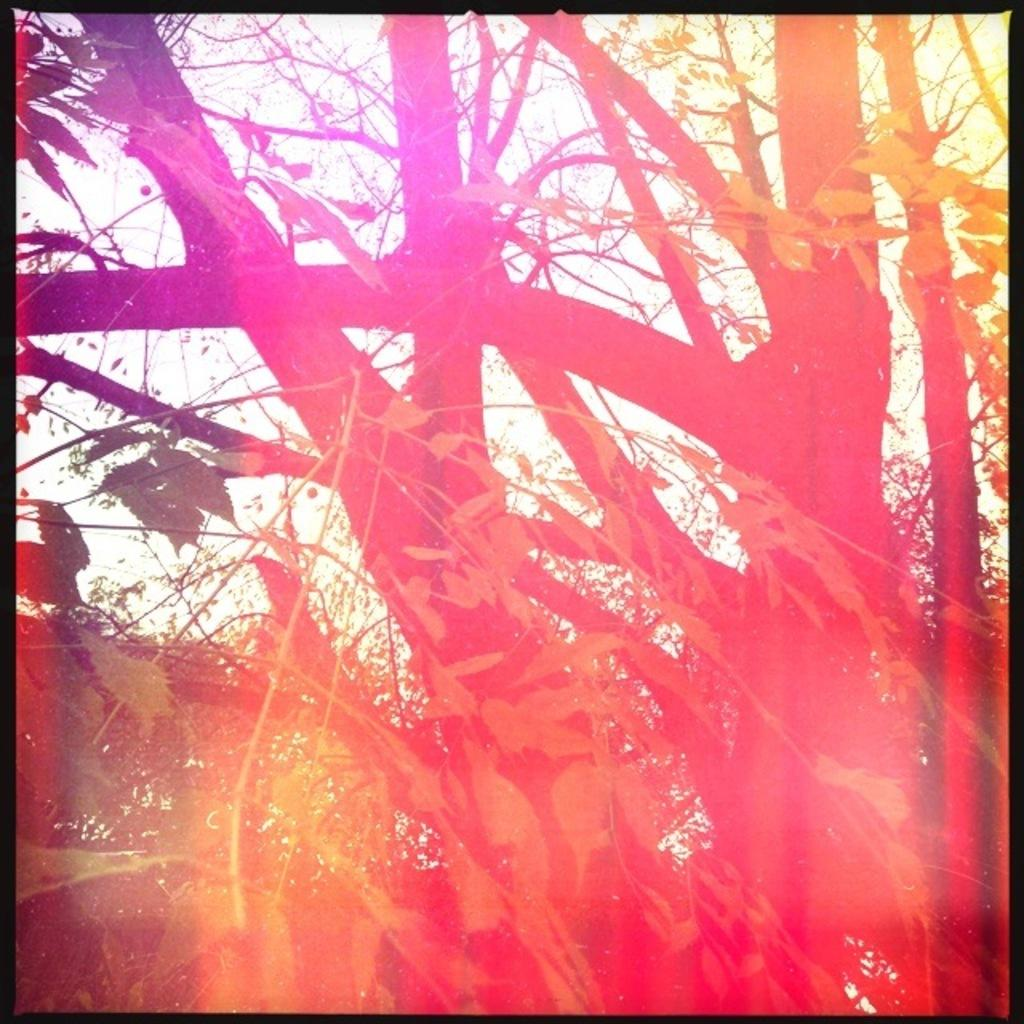What type of vegetation is present in the image? There is a group of trees in the image. What part of the trees can be seen in the image? There are leaves visible in the image. What can be seen in the background of the image? The sky is visible in the background of the image. Can you describe the woman holding the kitten in the image? There is no woman or kitten present in the image; it features a group of trees and leaves with the sky visible in the background. 